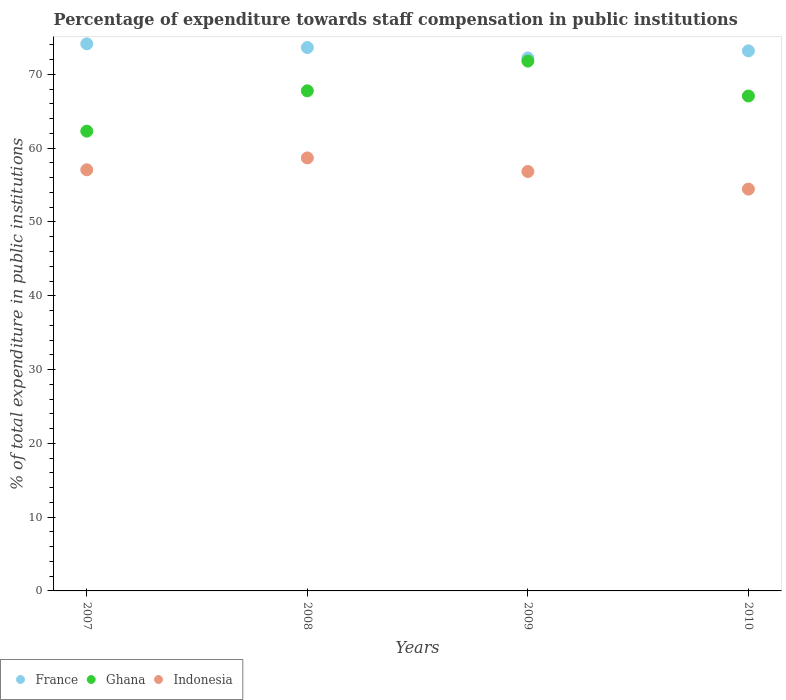How many different coloured dotlines are there?
Your response must be concise. 3. What is the percentage of expenditure towards staff compensation in France in 2010?
Provide a succinct answer. 73.19. Across all years, what is the maximum percentage of expenditure towards staff compensation in Indonesia?
Your answer should be very brief. 58.68. Across all years, what is the minimum percentage of expenditure towards staff compensation in Indonesia?
Offer a very short reply. 54.45. In which year was the percentage of expenditure towards staff compensation in Ghana maximum?
Offer a very short reply. 2009. In which year was the percentage of expenditure towards staff compensation in France minimum?
Ensure brevity in your answer.  2009. What is the total percentage of expenditure towards staff compensation in Indonesia in the graph?
Provide a short and direct response. 227.05. What is the difference between the percentage of expenditure towards staff compensation in Ghana in 2007 and that in 2009?
Your answer should be compact. -9.49. What is the difference between the percentage of expenditure towards staff compensation in France in 2007 and the percentage of expenditure towards staff compensation in Ghana in 2009?
Provide a short and direct response. 2.34. What is the average percentage of expenditure towards staff compensation in Indonesia per year?
Provide a succinct answer. 56.76. In the year 2007, what is the difference between the percentage of expenditure towards staff compensation in Ghana and percentage of expenditure towards staff compensation in France?
Provide a succinct answer. -11.83. In how many years, is the percentage of expenditure towards staff compensation in France greater than 56 %?
Offer a very short reply. 4. What is the ratio of the percentage of expenditure towards staff compensation in France in 2008 to that in 2009?
Provide a short and direct response. 1.02. Is the percentage of expenditure towards staff compensation in Ghana in 2007 less than that in 2009?
Provide a succinct answer. Yes. Is the difference between the percentage of expenditure towards staff compensation in Ghana in 2008 and 2009 greater than the difference between the percentage of expenditure towards staff compensation in France in 2008 and 2009?
Provide a succinct answer. No. What is the difference between the highest and the second highest percentage of expenditure towards staff compensation in France?
Your answer should be very brief. 0.5. What is the difference between the highest and the lowest percentage of expenditure towards staff compensation in Indonesia?
Make the answer very short. 4.23. Is it the case that in every year, the sum of the percentage of expenditure towards staff compensation in Ghana and percentage of expenditure towards staff compensation in Indonesia  is greater than the percentage of expenditure towards staff compensation in France?
Keep it short and to the point. Yes. How many dotlines are there?
Make the answer very short. 3. What is the difference between two consecutive major ticks on the Y-axis?
Keep it short and to the point. 10. Are the values on the major ticks of Y-axis written in scientific E-notation?
Your answer should be very brief. No. Where does the legend appear in the graph?
Offer a terse response. Bottom left. How are the legend labels stacked?
Offer a very short reply. Horizontal. What is the title of the graph?
Your response must be concise. Percentage of expenditure towards staff compensation in public institutions. Does "Sub-Saharan Africa (developing only)" appear as one of the legend labels in the graph?
Provide a short and direct response. No. What is the label or title of the Y-axis?
Your response must be concise. % of total expenditure in public institutions. What is the % of total expenditure in public institutions in France in 2007?
Keep it short and to the point. 74.14. What is the % of total expenditure in public institutions of Ghana in 2007?
Your answer should be compact. 62.31. What is the % of total expenditure in public institutions in Indonesia in 2007?
Provide a short and direct response. 57.07. What is the % of total expenditure in public institutions in France in 2008?
Provide a short and direct response. 73.64. What is the % of total expenditure in public institutions of Ghana in 2008?
Provide a succinct answer. 67.77. What is the % of total expenditure in public institutions of Indonesia in 2008?
Keep it short and to the point. 58.68. What is the % of total expenditure in public institutions of France in 2009?
Give a very brief answer. 72.22. What is the % of total expenditure in public institutions of Ghana in 2009?
Offer a terse response. 71.8. What is the % of total expenditure in public institutions of Indonesia in 2009?
Offer a very short reply. 56.84. What is the % of total expenditure in public institutions in France in 2010?
Offer a terse response. 73.19. What is the % of total expenditure in public institutions in Ghana in 2010?
Your response must be concise. 67.07. What is the % of total expenditure in public institutions in Indonesia in 2010?
Provide a succinct answer. 54.45. Across all years, what is the maximum % of total expenditure in public institutions of France?
Your answer should be compact. 74.14. Across all years, what is the maximum % of total expenditure in public institutions of Ghana?
Provide a succinct answer. 71.8. Across all years, what is the maximum % of total expenditure in public institutions of Indonesia?
Your answer should be very brief. 58.68. Across all years, what is the minimum % of total expenditure in public institutions of France?
Your answer should be compact. 72.22. Across all years, what is the minimum % of total expenditure in public institutions in Ghana?
Provide a succinct answer. 62.31. Across all years, what is the minimum % of total expenditure in public institutions in Indonesia?
Ensure brevity in your answer.  54.45. What is the total % of total expenditure in public institutions in France in the graph?
Provide a succinct answer. 293.19. What is the total % of total expenditure in public institutions in Ghana in the graph?
Offer a terse response. 268.96. What is the total % of total expenditure in public institutions of Indonesia in the graph?
Make the answer very short. 227.05. What is the difference between the % of total expenditure in public institutions in France in 2007 and that in 2008?
Ensure brevity in your answer.  0.5. What is the difference between the % of total expenditure in public institutions in Ghana in 2007 and that in 2008?
Provide a succinct answer. -5.46. What is the difference between the % of total expenditure in public institutions of Indonesia in 2007 and that in 2008?
Your response must be concise. -1.61. What is the difference between the % of total expenditure in public institutions in France in 2007 and that in 2009?
Provide a short and direct response. 1.92. What is the difference between the % of total expenditure in public institutions of Ghana in 2007 and that in 2009?
Your answer should be very brief. -9.49. What is the difference between the % of total expenditure in public institutions of Indonesia in 2007 and that in 2009?
Give a very brief answer. 0.23. What is the difference between the % of total expenditure in public institutions of France in 2007 and that in 2010?
Provide a succinct answer. 0.95. What is the difference between the % of total expenditure in public institutions in Ghana in 2007 and that in 2010?
Your answer should be very brief. -4.76. What is the difference between the % of total expenditure in public institutions of Indonesia in 2007 and that in 2010?
Provide a succinct answer. 2.62. What is the difference between the % of total expenditure in public institutions in France in 2008 and that in 2009?
Offer a terse response. 1.42. What is the difference between the % of total expenditure in public institutions in Ghana in 2008 and that in 2009?
Provide a short and direct response. -4.03. What is the difference between the % of total expenditure in public institutions of Indonesia in 2008 and that in 2009?
Keep it short and to the point. 1.84. What is the difference between the % of total expenditure in public institutions of France in 2008 and that in 2010?
Your answer should be compact. 0.45. What is the difference between the % of total expenditure in public institutions of Indonesia in 2008 and that in 2010?
Your answer should be very brief. 4.23. What is the difference between the % of total expenditure in public institutions in France in 2009 and that in 2010?
Offer a terse response. -0.97. What is the difference between the % of total expenditure in public institutions of Ghana in 2009 and that in 2010?
Your answer should be very brief. 4.73. What is the difference between the % of total expenditure in public institutions of Indonesia in 2009 and that in 2010?
Make the answer very short. 2.39. What is the difference between the % of total expenditure in public institutions in France in 2007 and the % of total expenditure in public institutions in Ghana in 2008?
Your response must be concise. 6.37. What is the difference between the % of total expenditure in public institutions of France in 2007 and the % of total expenditure in public institutions of Indonesia in 2008?
Your response must be concise. 15.46. What is the difference between the % of total expenditure in public institutions in Ghana in 2007 and the % of total expenditure in public institutions in Indonesia in 2008?
Provide a short and direct response. 3.63. What is the difference between the % of total expenditure in public institutions of France in 2007 and the % of total expenditure in public institutions of Ghana in 2009?
Make the answer very short. 2.34. What is the difference between the % of total expenditure in public institutions in France in 2007 and the % of total expenditure in public institutions in Indonesia in 2009?
Offer a terse response. 17.3. What is the difference between the % of total expenditure in public institutions of Ghana in 2007 and the % of total expenditure in public institutions of Indonesia in 2009?
Your answer should be compact. 5.47. What is the difference between the % of total expenditure in public institutions of France in 2007 and the % of total expenditure in public institutions of Ghana in 2010?
Make the answer very short. 7.07. What is the difference between the % of total expenditure in public institutions in France in 2007 and the % of total expenditure in public institutions in Indonesia in 2010?
Keep it short and to the point. 19.69. What is the difference between the % of total expenditure in public institutions in Ghana in 2007 and the % of total expenditure in public institutions in Indonesia in 2010?
Make the answer very short. 7.85. What is the difference between the % of total expenditure in public institutions in France in 2008 and the % of total expenditure in public institutions in Ghana in 2009?
Offer a very short reply. 1.84. What is the difference between the % of total expenditure in public institutions of France in 2008 and the % of total expenditure in public institutions of Indonesia in 2009?
Your answer should be very brief. 16.8. What is the difference between the % of total expenditure in public institutions in Ghana in 2008 and the % of total expenditure in public institutions in Indonesia in 2009?
Ensure brevity in your answer.  10.93. What is the difference between the % of total expenditure in public institutions of France in 2008 and the % of total expenditure in public institutions of Ghana in 2010?
Provide a succinct answer. 6.57. What is the difference between the % of total expenditure in public institutions in France in 2008 and the % of total expenditure in public institutions in Indonesia in 2010?
Your answer should be compact. 19.19. What is the difference between the % of total expenditure in public institutions of Ghana in 2008 and the % of total expenditure in public institutions of Indonesia in 2010?
Offer a terse response. 13.32. What is the difference between the % of total expenditure in public institutions in France in 2009 and the % of total expenditure in public institutions in Ghana in 2010?
Offer a very short reply. 5.15. What is the difference between the % of total expenditure in public institutions of France in 2009 and the % of total expenditure in public institutions of Indonesia in 2010?
Give a very brief answer. 17.77. What is the difference between the % of total expenditure in public institutions in Ghana in 2009 and the % of total expenditure in public institutions in Indonesia in 2010?
Provide a succinct answer. 17.35. What is the average % of total expenditure in public institutions of France per year?
Make the answer very short. 73.3. What is the average % of total expenditure in public institutions in Ghana per year?
Keep it short and to the point. 67.24. What is the average % of total expenditure in public institutions in Indonesia per year?
Your answer should be very brief. 56.76. In the year 2007, what is the difference between the % of total expenditure in public institutions of France and % of total expenditure in public institutions of Ghana?
Your answer should be very brief. 11.83. In the year 2007, what is the difference between the % of total expenditure in public institutions of France and % of total expenditure in public institutions of Indonesia?
Offer a terse response. 17.07. In the year 2007, what is the difference between the % of total expenditure in public institutions in Ghana and % of total expenditure in public institutions in Indonesia?
Your response must be concise. 5.23. In the year 2008, what is the difference between the % of total expenditure in public institutions in France and % of total expenditure in public institutions in Ghana?
Your response must be concise. 5.87. In the year 2008, what is the difference between the % of total expenditure in public institutions of France and % of total expenditure in public institutions of Indonesia?
Your answer should be compact. 14.96. In the year 2008, what is the difference between the % of total expenditure in public institutions in Ghana and % of total expenditure in public institutions in Indonesia?
Your answer should be compact. 9.09. In the year 2009, what is the difference between the % of total expenditure in public institutions of France and % of total expenditure in public institutions of Ghana?
Offer a very short reply. 0.42. In the year 2009, what is the difference between the % of total expenditure in public institutions of France and % of total expenditure in public institutions of Indonesia?
Offer a very short reply. 15.38. In the year 2009, what is the difference between the % of total expenditure in public institutions in Ghana and % of total expenditure in public institutions in Indonesia?
Offer a terse response. 14.96. In the year 2010, what is the difference between the % of total expenditure in public institutions of France and % of total expenditure in public institutions of Ghana?
Your answer should be very brief. 6.12. In the year 2010, what is the difference between the % of total expenditure in public institutions in France and % of total expenditure in public institutions in Indonesia?
Keep it short and to the point. 18.74. In the year 2010, what is the difference between the % of total expenditure in public institutions in Ghana and % of total expenditure in public institutions in Indonesia?
Give a very brief answer. 12.62. What is the ratio of the % of total expenditure in public institutions of France in 2007 to that in 2008?
Provide a short and direct response. 1.01. What is the ratio of the % of total expenditure in public institutions of Ghana in 2007 to that in 2008?
Your response must be concise. 0.92. What is the ratio of the % of total expenditure in public institutions of Indonesia in 2007 to that in 2008?
Ensure brevity in your answer.  0.97. What is the ratio of the % of total expenditure in public institutions of France in 2007 to that in 2009?
Keep it short and to the point. 1.03. What is the ratio of the % of total expenditure in public institutions of Ghana in 2007 to that in 2009?
Ensure brevity in your answer.  0.87. What is the ratio of the % of total expenditure in public institutions of Indonesia in 2007 to that in 2009?
Your answer should be compact. 1. What is the ratio of the % of total expenditure in public institutions in France in 2007 to that in 2010?
Provide a short and direct response. 1.01. What is the ratio of the % of total expenditure in public institutions of Ghana in 2007 to that in 2010?
Provide a succinct answer. 0.93. What is the ratio of the % of total expenditure in public institutions in Indonesia in 2007 to that in 2010?
Give a very brief answer. 1.05. What is the ratio of the % of total expenditure in public institutions in France in 2008 to that in 2009?
Make the answer very short. 1.02. What is the ratio of the % of total expenditure in public institutions of Ghana in 2008 to that in 2009?
Your answer should be compact. 0.94. What is the ratio of the % of total expenditure in public institutions in Indonesia in 2008 to that in 2009?
Make the answer very short. 1.03. What is the ratio of the % of total expenditure in public institutions in Ghana in 2008 to that in 2010?
Make the answer very short. 1.01. What is the ratio of the % of total expenditure in public institutions of Indonesia in 2008 to that in 2010?
Offer a terse response. 1.08. What is the ratio of the % of total expenditure in public institutions of France in 2009 to that in 2010?
Your response must be concise. 0.99. What is the ratio of the % of total expenditure in public institutions of Ghana in 2009 to that in 2010?
Offer a terse response. 1.07. What is the ratio of the % of total expenditure in public institutions in Indonesia in 2009 to that in 2010?
Offer a very short reply. 1.04. What is the difference between the highest and the second highest % of total expenditure in public institutions of France?
Make the answer very short. 0.5. What is the difference between the highest and the second highest % of total expenditure in public institutions of Ghana?
Your answer should be very brief. 4.03. What is the difference between the highest and the second highest % of total expenditure in public institutions of Indonesia?
Give a very brief answer. 1.61. What is the difference between the highest and the lowest % of total expenditure in public institutions of France?
Offer a very short reply. 1.92. What is the difference between the highest and the lowest % of total expenditure in public institutions of Ghana?
Your response must be concise. 9.49. What is the difference between the highest and the lowest % of total expenditure in public institutions in Indonesia?
Your response must be concise. 4.23. 